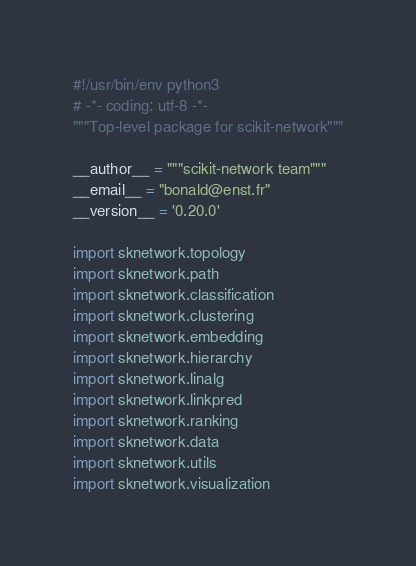<code> <loc_0><loc_0><loc_500><loc_500><_Python_>#!/usr/bin/env python3
# -*- coding: utf-8 -*-
"""Top-level package for scikit-network"""

__author__ = """scikit-network team"""
__email__ = "bonald@enst.fr"
__version__ = '0.20.0'

import sknetwork.topology
import sknetwork.path
import sknetwork.classification
import sknetwork.clustering
import sknetwork.embedding
import sknetwork.hierarchy
import sknetwork.linalg
import sknetwork.linkpred
import sknetwork.ranking
import sknetwork.data
import sknetwork.utils
import sknetwork.visualization
</code> 